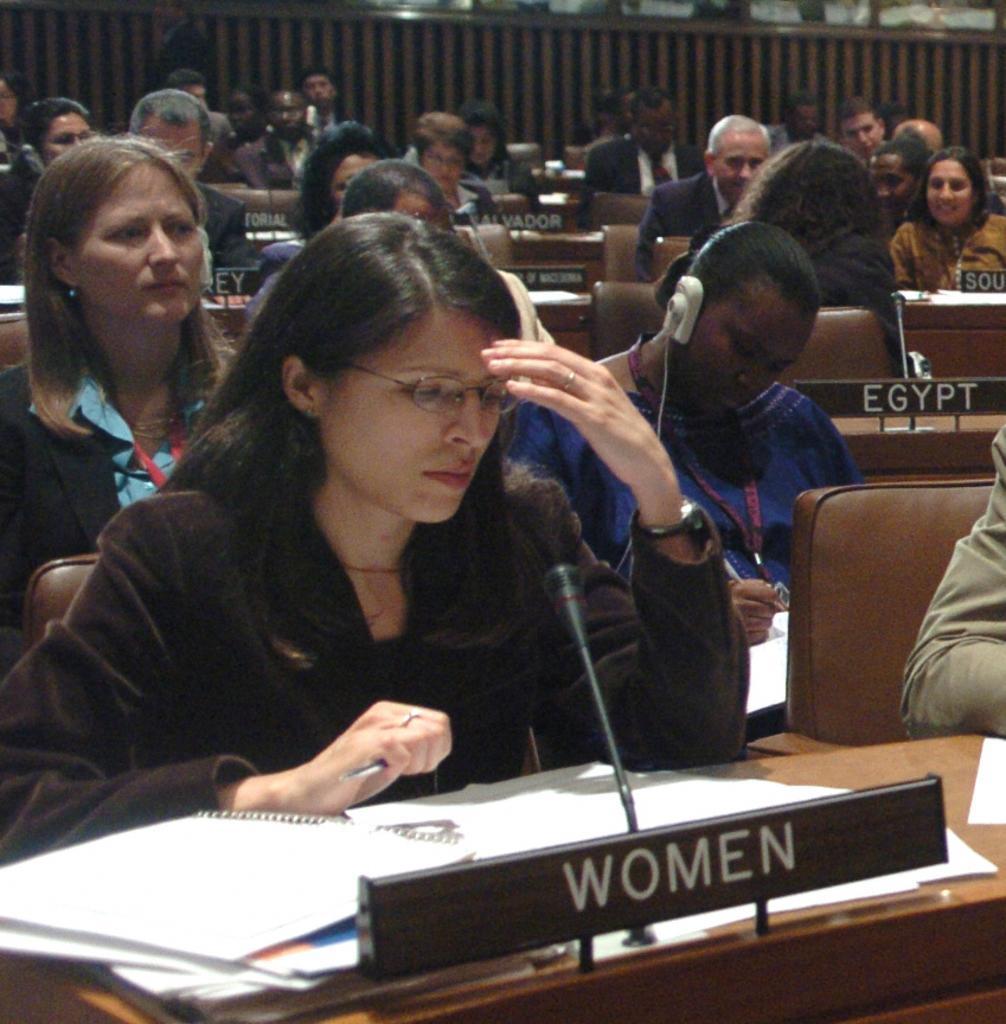Describe this image in one or two sentences. In this image I can see the group of people sitting in front of the table with mic and books on it. And there a name women is written on the table. And there is a person wearing headset. 